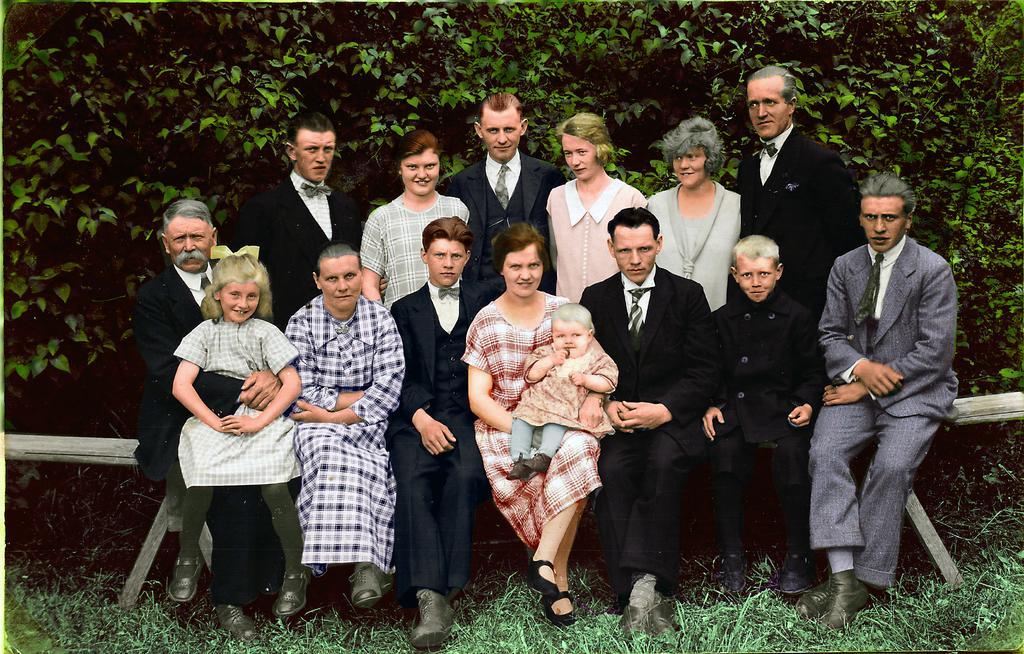What type of artwork is depicted in the image? The image is a painting. What are the people in the painting doing? There are people sitting on a bench and standing in the painting. What type of landscape is shown in the painting? There is grass and trees with branches and leaves in the painting. What type of stone is being used as a prop by the people in the painting? There is no stone present in the painting; the people are sitting on a bench and standing. Is the painting a work of fiction or non-fiction? The painting is a work of fiction, as it is an artistic representation rather than a factual depiction. --- 